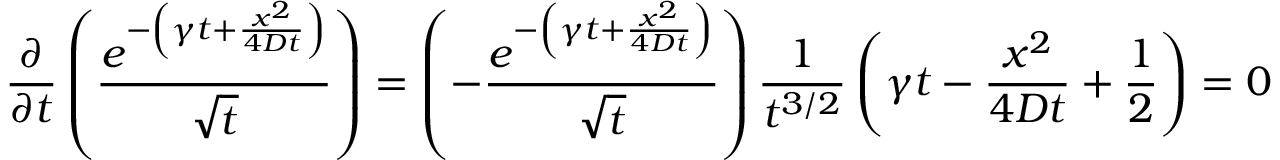<formula> <loc_0><loc_0><loc_500><loc_500>\frac { \partial } { \partial t } \left ( \frac { e ^ { - \left ( \gamma t + \frac { x ^ { 2 } } { 4 D t } \right ) } } { \sqrt { t } } \right ) = \left ( - \frac { e ^ { - \left ( \gamma t + \frac { x ^ { 2 } } { 4 D t } \right ) } } { \sqrt { t } } \right ) \frac { 1 } { t ^ { 3 / 2 } } \left ( \gamma t - \frac { x ^ { 2 } } { 4 D t } + \frac { 1 } { 2 } \right ) = 0</formula> 